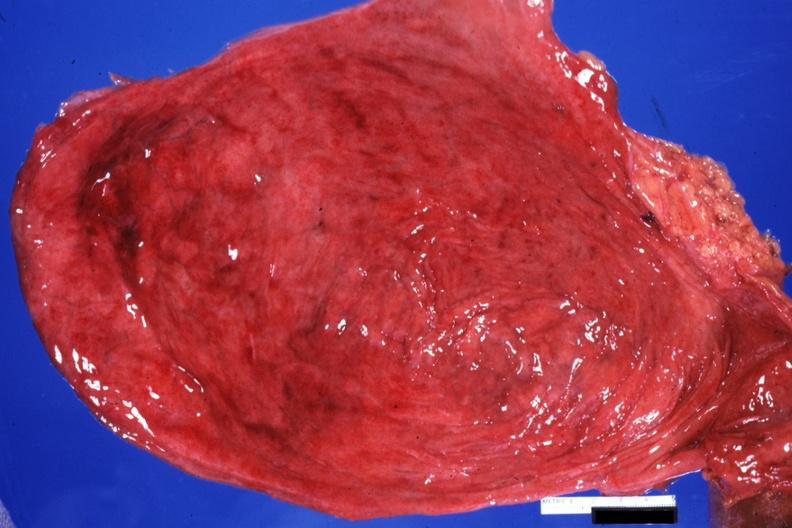where is this?
Answer the question using a single word or phrase. Urinary 